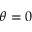<formula> <loc_0><loc_0><loc_500><loc_500>\theta = 0</formula> 